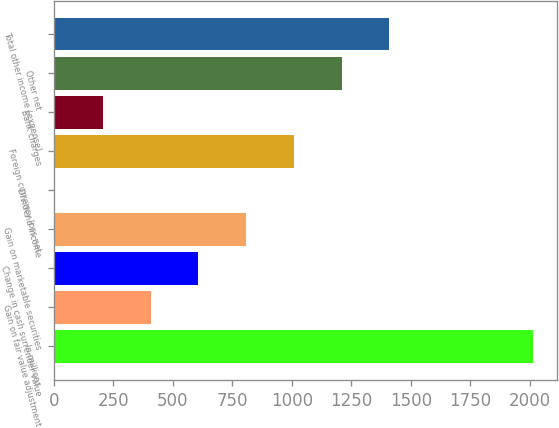<chart> <loc_0><loc_0><loc_500><loc_500><bar_chart><fcel>In millions<fcel>Gain on fair value adjustment<fcel>Change in cash surrender value<fcel>Gain on marketable securities<fcel>Dividend income<fcel>Foreign currency loss net<fcel>Bank charges<fcel>Other net<fcel>Total other income (expense)<nl><fcel>2013<fcel>406.6<fcel>607.4<fcel>808.2<fcel>5<fcel>1009<fcel>205.8<fcel>1209.8<fcel>1410.6<nl></chart> 